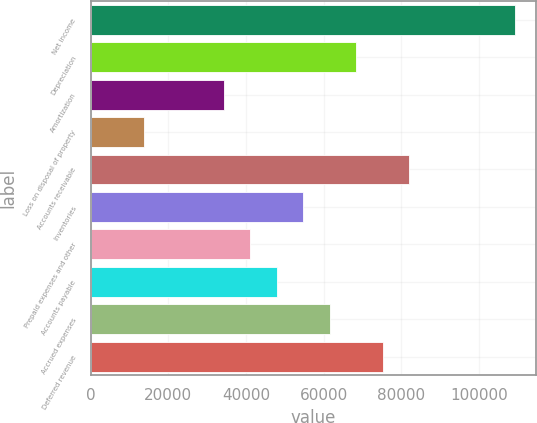<chart> <loc_0><loc_0><loc_500><loc_500><bar_chart><fcel>Net income<fcel>Depreciation<fcel>Amortization<fcel>Loss on disposal of property<fcel>Accounts receivable<fcel>Inventories<fcel>Prepaid expenses and other<fcel>Accounts payable<fcel>Accrued expenses<fcel>Deferred revenue<nl><fcel>109251<fcel>68335<fcel>34238<fcel>13779.8<fcel>81973.8<fcel>54696.2<fcel>41057.4<fcel>47876.8<fcel>61515.6<fcel>75154.4<nl></chart> 